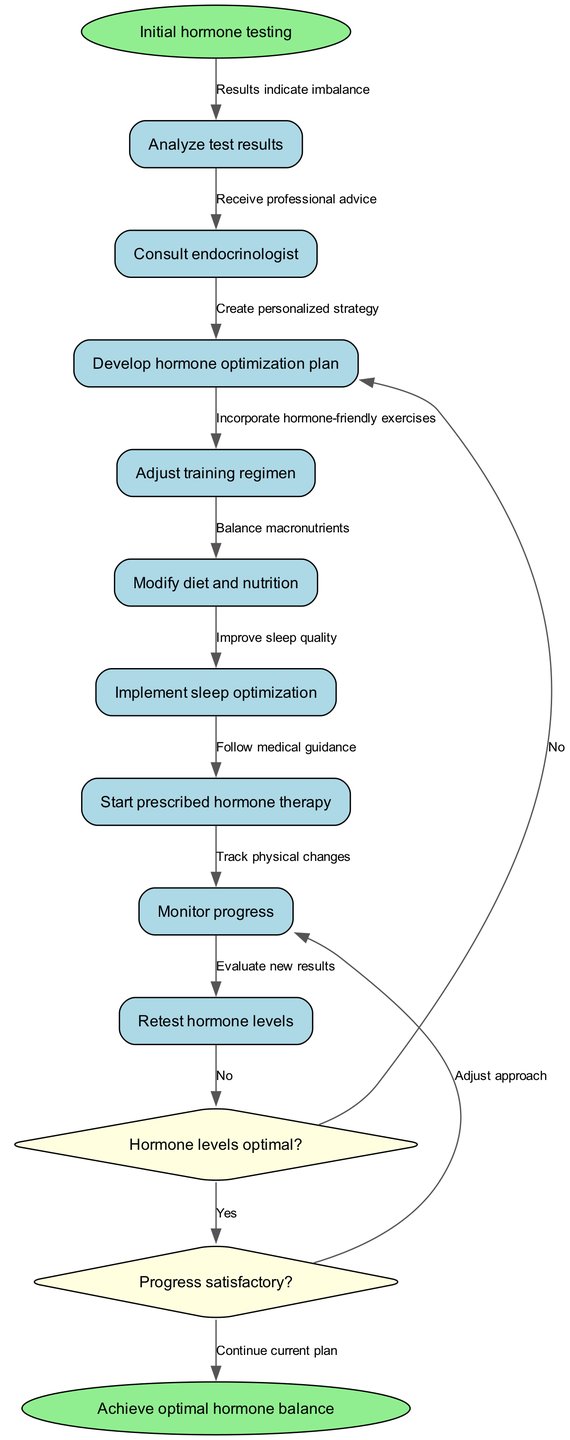What is the first activity in the diagram? The first activity listed in the diagram is "Analyze test results," which comes immediately after the starting point of "Initial hormone testing."
Answer: Analyze test results How many activities are depicted in the diagram? There are 9 activities shown in the diagram, as indicated by the count of nodes labeled as activities.
Answer: 9 What happens if hormone levels are optimal after monitoring progress? If hormone levels are optimal, the next step in the diagram is to move to end node "Achieve optimal hormone balance," indicating a successful conclusion to the hormone optimization journey.
Answer: Achieve optimal hormone balance What is the last activity before the decision nodes? The last activity before reaching the decision nodes is "Monitor progress," which evaluates the improvements in hormone levels before deciding on the next steps.
Answer: Monitor progress What decision determines if a plan should be adjusted? The decision "Progress satisfactory?" affects whether the current plan continues or changes, determining the next course of action based on the results of the progress monitoring.
Answer: Progress satisfactory? What activity follows "Start prescribed hormone therapy"? After "Start prescribed hormone therapy," the next activity is "Monitor progress," which assesses any changes to hormone levels or overall health post-therapy.
Answer: Monitor progress Which activity involves dietary changes? The activity that involves dietary changes is "Modify diet and nutrition," which focuses on adjusting the bodybuilder's nutritional intake to support hormone balance.
Answer: Modify diet and nutrition What decision point indicates possible re-evaluation of the hormone optimization plan? The decision "Hormone levels optimal?" signifies whether the current hormone optimization efforts were successful or if re-evaluation is necessary, leading either to adjustments or to achieving balance.
Answer: Hormone levels optimal? How many decision nodes are there in the diagram? There are 2 decision nodes shown in the diagram, each requiring evaluation to decide the next steps in the hormone optimization journey.
Answer: 2 